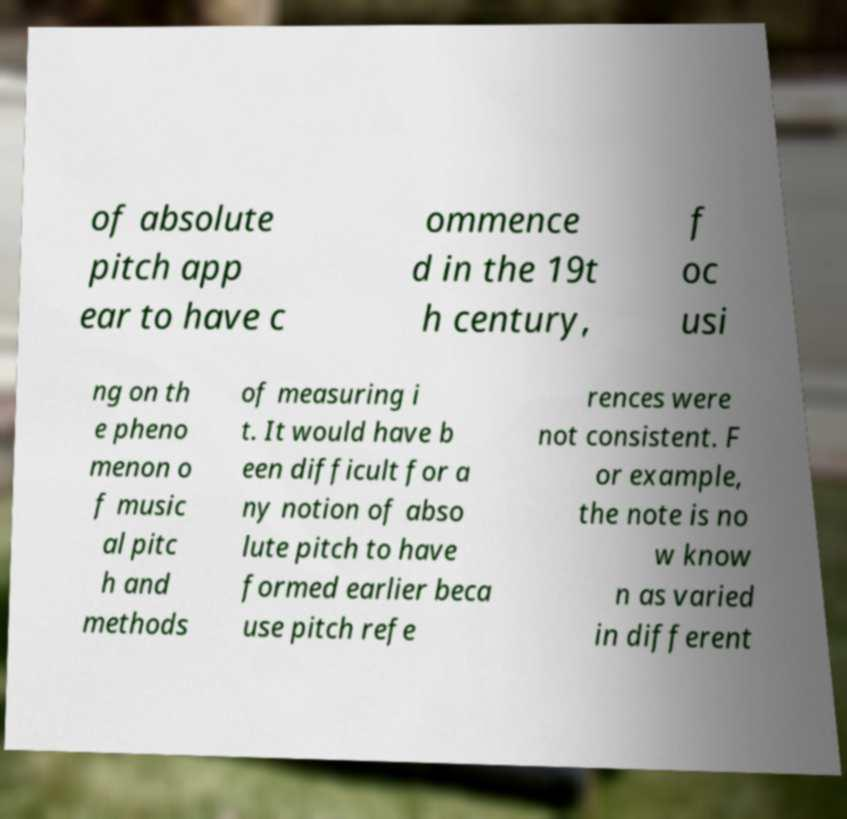What messages or text are displayed in this image? I need them in a readable, typed format. of absolute pitch app ear to have c ommence d in the 19t h century, f oc usi ng on th e pheno menon o f music al pitc h and methods of measuring i t. It would have b een difficult for a ny notion of abso lute pitch to have formed earlier beca use pitch refe rences were not consistent. F or example, the note is no w know n as varied in different 